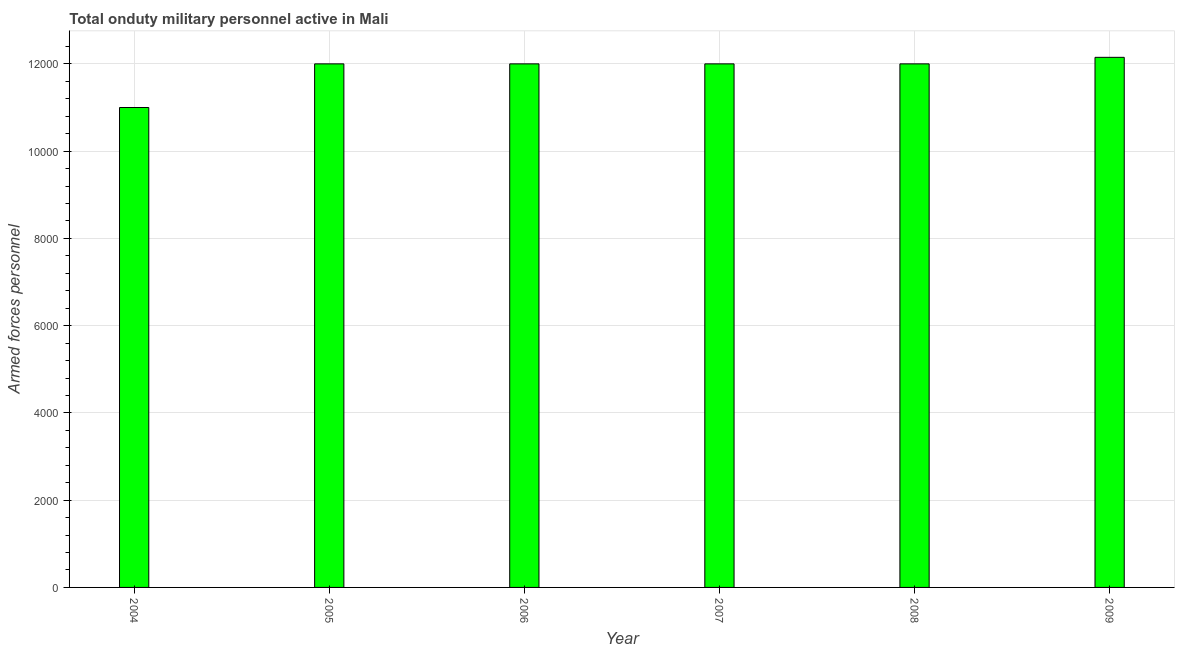Does the graph contain grids?
Make the answer very short. Yes. What is the title of the graph?
Your answer should be compact. Total onduty military personnel active in Mali. What is the label or title of the Y-axis?
Make the answer very short. Armed forces personnel. What is the number of armed forces personnel in 2004?
Keep it short and to the point. 1.10e+04. Across all years, what is the maximum number of armed forces personnel?
Your answer should be compact. 1.22e+04. Across all years, what is the minimum number of armed forces personnel?
Offer a terse response. 1.10e+04. In which year was the number of armed forces personnel maximum?
Offer a terse response. 2009. In which year was the number of armed forces personnel minimum?
Offer a very short reply. 2004. What is the sum of the number of armed forces personnel?
Your answer should be very brief. 7.12e+04. What is the difference between the number of armed forces personnel in 2004 and 2008?
Offer a very short reply. -1000. What is the average number of armed forces personnel per year?
Offer a terse response. 1.19e+04. What is the median number of armed forces personnel?
Give a very brief answer. 1.20e+04. Do a majority of the years between 2006 and 2005 (inclusive) have number of armed forces personnel greater than 7200 ?
Give a very brief answer. No. Is the number of armed forces personnel in 2006 less than that in 2009?
Offer a terse response. Yes. Is the difference between the number of armed forces personnel in 2005 and 2007 greater than the difference between any two years?
Offer a terse response. No. What is the difference between the highest and the second highest number of armed forces personnel?
Ensure brevity in your answer.  150. What is the difference between the highest and the lowest number of armed forces personnel?
Your response must be concise. 1150. How many bars are there?
Offer a terse response. 6. How many years are there in the graph?
Provide a succinct answer. 6. Are the values on the major ticks of Y-axis written in scientific E-notation?
Provide a short and direct response. No. What is the Armed forces personnel in 2004?
Offer a terse response. 1.10e+04. What is the Armed forces personnel of 2005?
Your answer should be very brief. 1.20e+04. What is the Armed forces personnel of 2006?
Give a very brief answer. 1.20e+04. What is the Armed forces personnel of 2007?
Give a very brief answer. 1.20e+04. What is the Armed forces personnel of 2008?
Your answer should be very brief. 1.20e+04. What is the Armed forces personnel in 2009?
Ensure brevity in your answer.  1.22e+04. What is the difference between the Armed forces personnel in 2004 and 2005?
Ensure brevity in your answer.  -1000. What is the difference between the Armed forces personnel in 2004 and 2006?
Your response must be concise. -1000. What is the difference between the Armed forces personnel in 2004 and 2007?
Provide a succinct answer. -1000. What is the difference between the Armed forces personnel in 2004 and 2008?
Provide a short and direct response. -1000. What is the difference between the Armed forces personnel in 2004 and 2009?
Offer a terse response. -1150. What is the difference between the Armed forces personnel in 2005 and 2006?
Keep it short and to the point. 0. What is the difference between the Armed forces personnel in 2005 and 2009?
Your response must be concise. -150. What is the difference between the Armed forces personnel in 2006 and 2008?
Provide a short and direct response. 0. What is the difference between the Armed forces personnel in 2006 and 2009?
Your answer should be very brief. -150. What is the difference between the Armed forces personnel in 2007 and 2009?
Ensure brevity in your answer.  -150. What is the difference between the Armed forces personnel in 2008 and 2009?
Offer a very short reply. -150. What is the ratio of the Armed forces personnel in 2004 to that in 2005?
Give a very brief answer. 0.92. What is the ratio of the Armed forces personnel in 2004 to that in 2006?
Give a very brief answer. 0.92. What is the ratio of the Armed forces personnel in 2004 to that in 2007?
Your answer should be compact. 0.92. What is the ratio of the Armed forces personnel in 2004 to that in 2008?
Ensure brevity in your answer.  0.92. What is the ratio of the Armed forces personnel in 2004 to that in 2009?
Give a very brief answer. 0.91. What is the ratio of the Armed forces personnel in 2005 to that in 2006?
Provide a short and direct response. 1. What is the ratio of the Armed forces personnel in 2005 to that in 2007?
Give a very brief answer. 1. What is the ratio of the Armed forces personnel in 2006 to that in 2007?
Provide a short and direct response. 1. What is the ratio of the Armed forces personnel in 2006 to that in 2008?
Keep it short and to the point. 1. What is the ratio of the Armed forces personnel in 2006 to that in 2009?
Give a very brief answer. 0.99. What is the ratio of the Armed forces personnel in 2007 to that in 2009?
Make the answer very short. 0.99. 